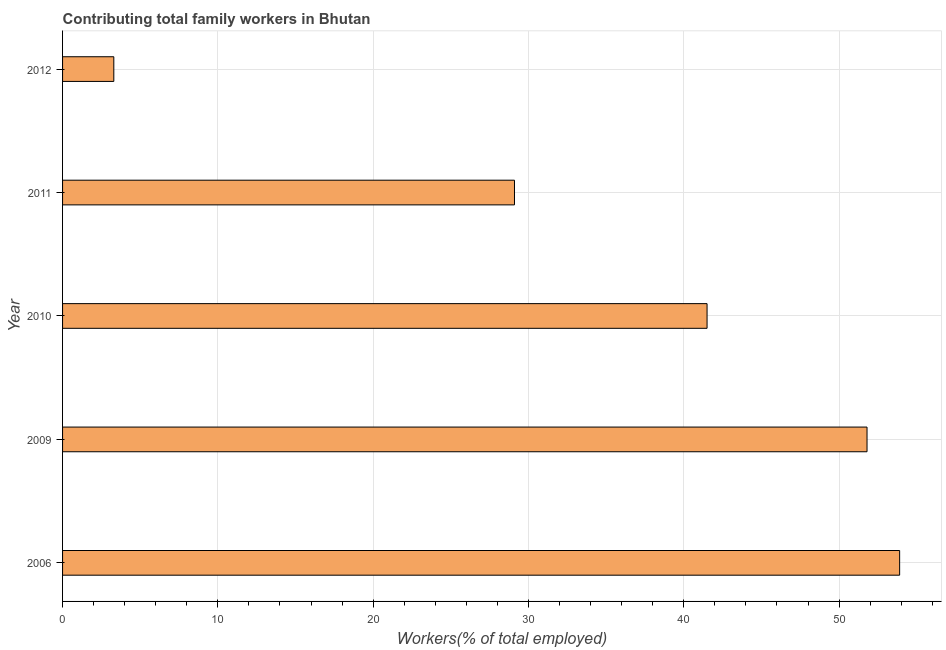What is the title of the graph?
Keep it short and to the point. Contributing total family workers in Bhutan. What is the label or title of the X-axis?
Offer a very short reply. Workers(% of total employed). What is the contributing family workers in 2010?
Your answer should be compact. 41.5. Across all years, what is the maximum contributing family workers?
Your answer should be very brief. 53.9. Across all years, what is the minimum contributing family workers?
Make the answer very short. 3.3. In which year was the contributing family workers minimum?
Make the answer very short. 2012. What is the sum of the contributing family workers?
Your answer should be very brief. 179.6. What is the difference between the contributing family workers in 2006 and 2010?
Keep it short and to the point. 12.4. What is the average contributing family workers per year?
Provide a short and direct response. 35.92. What is the median contributing family workers?
Give a very brief answer. 41.5. In how many years, is the contributing family workers greater than 42 %?
Ensure brevity in your answer.  2. What is the ratio of the contributing family workers in 2009 to that in 2010?
Your response must be concise. 1.25. Is the sum of the contributing family workers in 2010 and 2011 greater than the maximum contributing family workers across all years?
Give a very brief answer. Yes. What is the difference between the highest and the lowest contributing family workers?
Make the answer very short. 50.6. How many bars are there?
Offer a very short reply. 5. Are all the bars in the graph horizontal?
Offer a terse response. Yes. How many years are there in the graph?
Your response must be concise. 5. What is the difference between two consecutive major ticks on the X-axis?
Offer a terse response. 10. Are the values on the major ticks of X-axis written in scientific E-notation?
Give a very brief answer. No. What is the Workers(% of total employed) in 2006?
Offer a very short reply. 53.9. What is the Workers(% of total employed) in 2009?
Your answer should be very brief. 51.8. What is the Workers(% of total employed) in 2010?
Ensure brevity in your answer.  41.5. What is the Workers(% of total employed) of 2011?
Ensure brevity in your answer.  29.1. What is the Workers(% of total employed) of 2012?
Offer a very short reply. 3.3. What is the difference between the Workers(% of total employed) in 2006 and 2011?
Your answer should be very brief. 24.8. What is the difference between the Workers(% of total employed) in 2006 and 2012?
Offer a very short reply. 50.6. What is the difference between the Workers(% of total employed) in 2009 and 2011?
Provide a short and direct response. 22.7. What is the difference between the Workers(% of total employed) in 2009 and 2012?
Your answer should be compact. 48.5. What is the difference between the Workers(% of total employed) in 2010 and 2012?
Keep it short and to the point. 38.2. What is the difference between the Workers(% of total employed) in 2011 and 2012?
Give a very brief answer. 25.8. What is the ratio of the Workers(% of total employed) in 2006 to that in 2009?
Offer a very short reply. 1.04. What is the ratio of the Workers(% of total employed) in 2006 to that in 2010?
Keep it short and to the point. 1.3. What is the ratio of the Workers(% of total employed) in 2006 to that in 2011?
Your answer should be compact. 1.85. What is the ratio of the Workers(% of total employed) in 2006 to that in 2012?
Give a very brief answer. 16.33. What is the ratio of the Workers(% of total employed) in 2009 to that in 2010?
Your answer should be very brief. 1.25. What is the ratio of the Workers(% of total employed) in 2009 to that in 2011?
Ensure brevity in your answer.  1.78. What is the ratio of the Workers(% of total employed) in 2009 to that in 2012?
Ensure brevity in your answer.  15.7. What is the ratio of the Workers(% of total employed) in 2010 to that in 2011?
Offer a terse response. 1.43. What is the ratio of the Workers(% of total employed) in 2010 to that in 2012?
Give a very brief answer. 12.58. What is the ratio of the Workers(% of total employed) in 2011 to that in 2012?
Offer a very short reply. 8.82. 